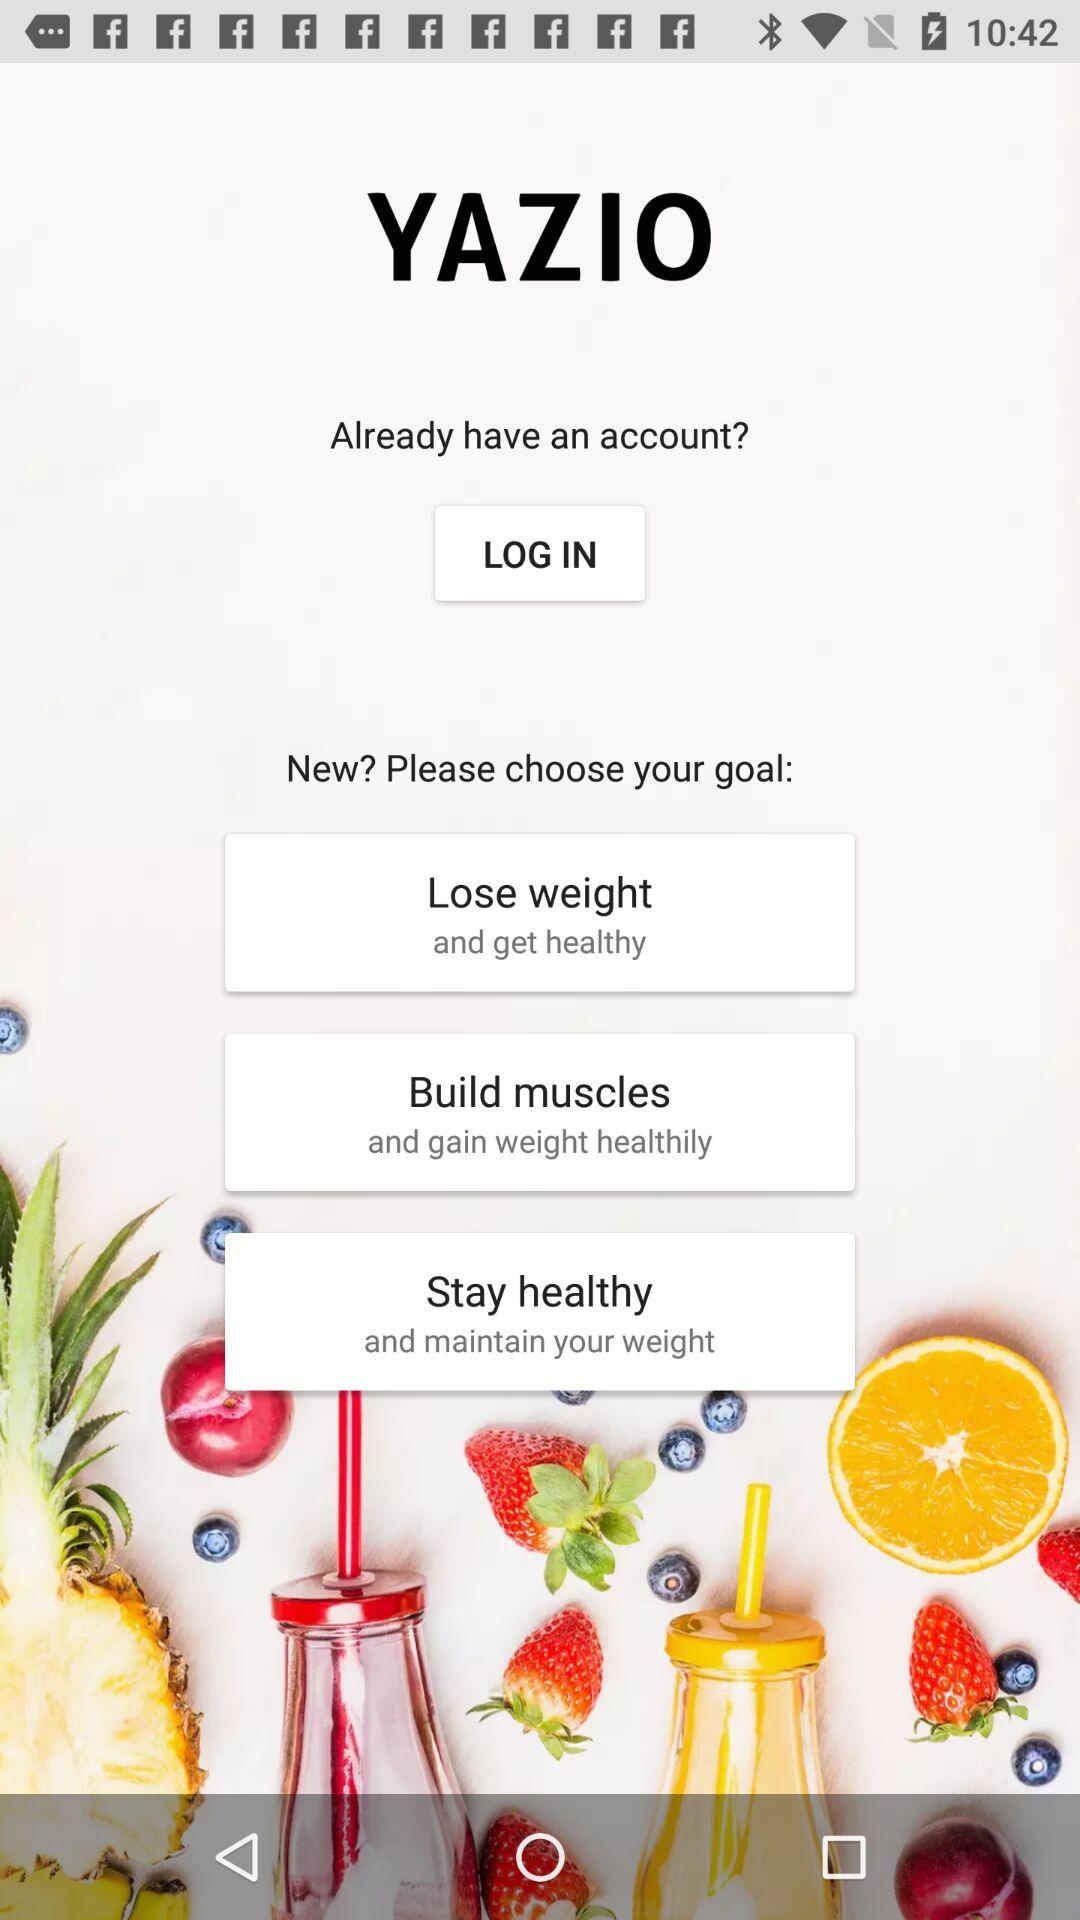What are the different types of goals mentioned? The different types of goals mentioned are "Lose weight", "Build muscles" and "Stay healthy". 